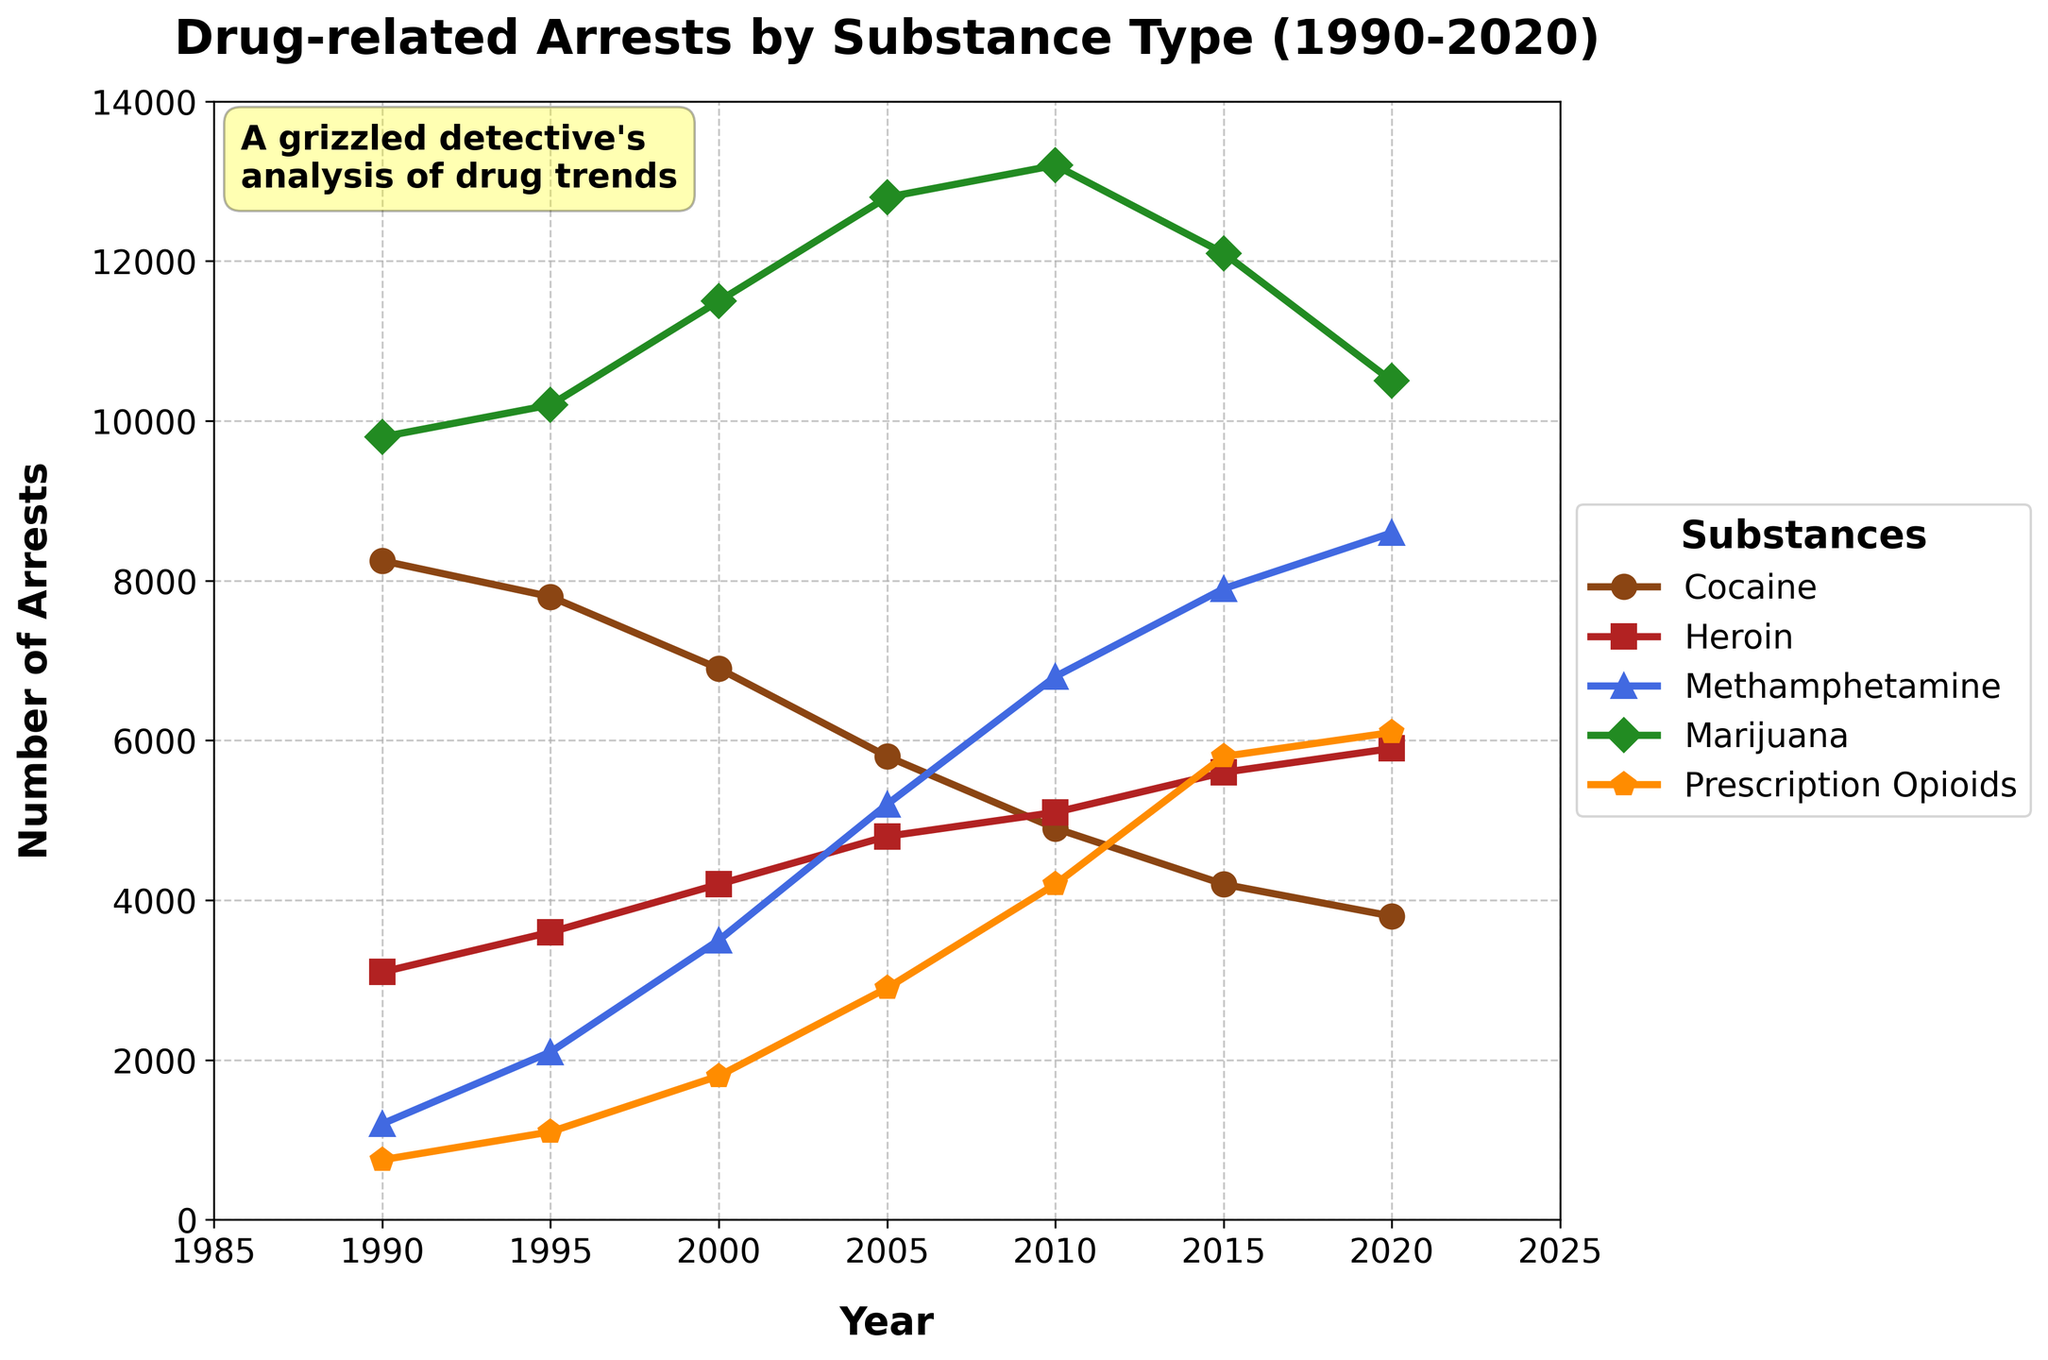What is the trend of cocaine-related arrests from 1990 to 2020? The number of cocaine-related arrests shows a decreasing trend over the years. Starting at 8250 in 1990, it gradually drops to 3800 in 2020.
Answer: Decreasing trend How do arrests for prescription opioids in 2010 compare to those in 2020? In 2010, there were 4200 arrests for prescription opioids, and this number increased to 6100 by 2020.
Answer: Increased Which substance had the highest number of arrests in 2005? In 2005, marijuana had the highest number of arrests with 12800.
Answer: Marijuana What is the difference in the number of methamphetamine-related arrests between 1990 and 2020? In 1990, there were 1200 arrests for methamphetamine, and in 2020, the number increased to 8600. The difference is 8600 - 1200 = 7400.
Answer: 7400 What was the average number of heroin-related arrests from 1990 to 2020? Summing the heroin-related arrests from each year (3100 + 3600 + 4200 + 4800 + 5100 + 5600 + 5900 = 32300) and dividing by the number of years (7), the average is 32300 / 7 ≈ 4614.29.
Answer: 4614.29 Which year had the highest total number of arrests across all substances? The total number of arrests for each year can be calculated as follows: 
1990: 32800, 1995: 34800, 2000: 35900, 2005: 37500, 2010: 39300, 2015: 37800, 2020: 34900. The highest total number of arrests was in 2010 with 39300.
Answer: 2010 Did the number of marijuana-related arrests ever decrease from one measured interval to the next? If so, when? Yes, the number of marijuana-related arrests decreased from 2010 to 2015, from 13200 to 12100.
Answer: 2010 to 2015 In what year did methamphetamine-related arrests surpass heroin-related arrests? Methamphetamine-related arrests surpassed heroin-related arrests in 2005.
Answer: 2005 Which substance showed the most consistent increase in arrests from 1990 to 2020? Prescription opioids showed the most consistent increase in arrests, rising steadily from 750 in 1990 to 6100 in 2020.
Answer: Prescription opioids 